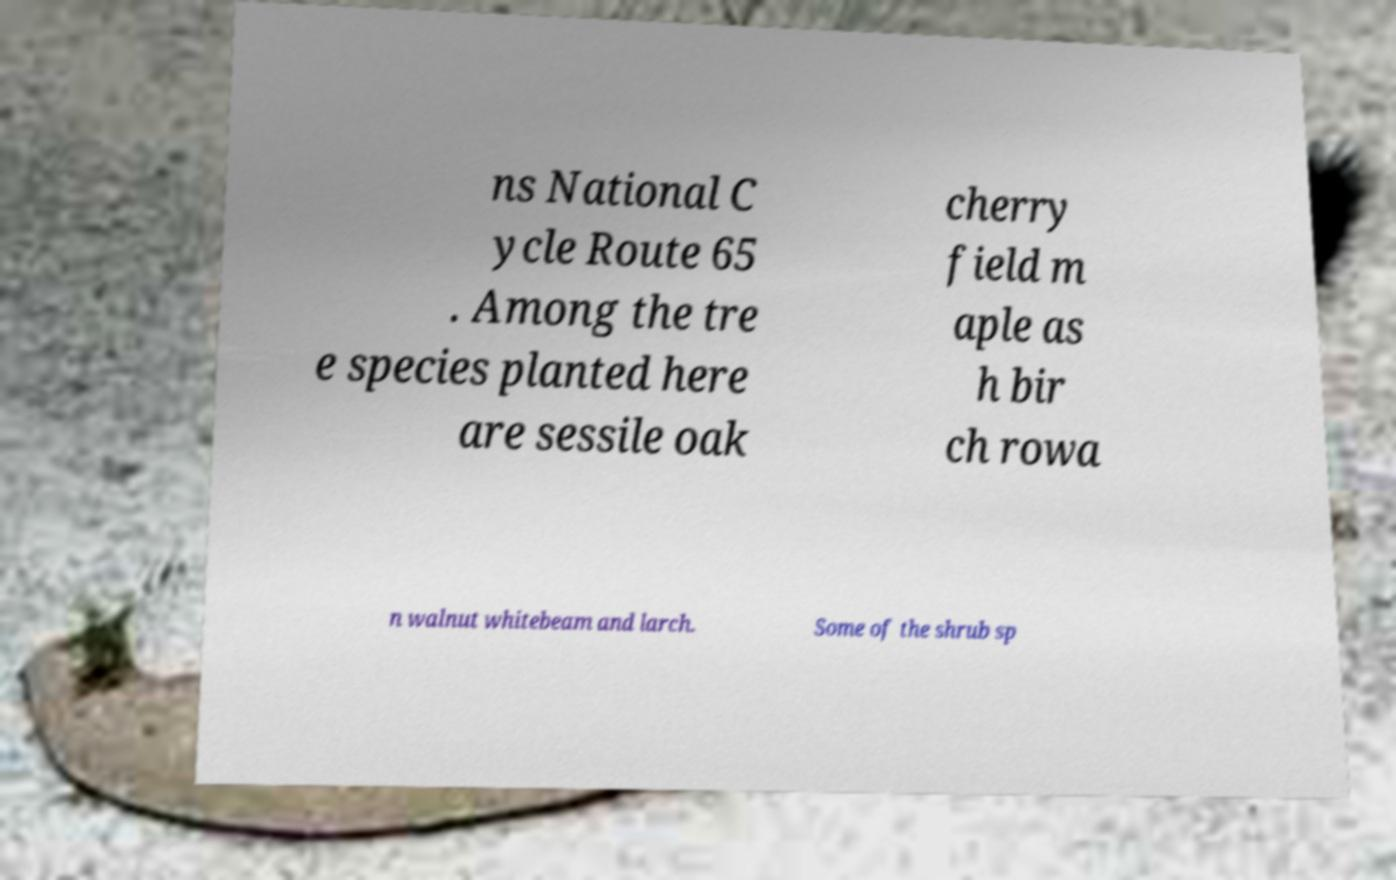Can you accurately transcribe the text from the provided image for me? ns National C ycle Route 65 . Among the tre e species planted here are sessile oak cherry field m aple as h bir ch rowa n walnut whitebeam and larch. Some of the shrub sp 